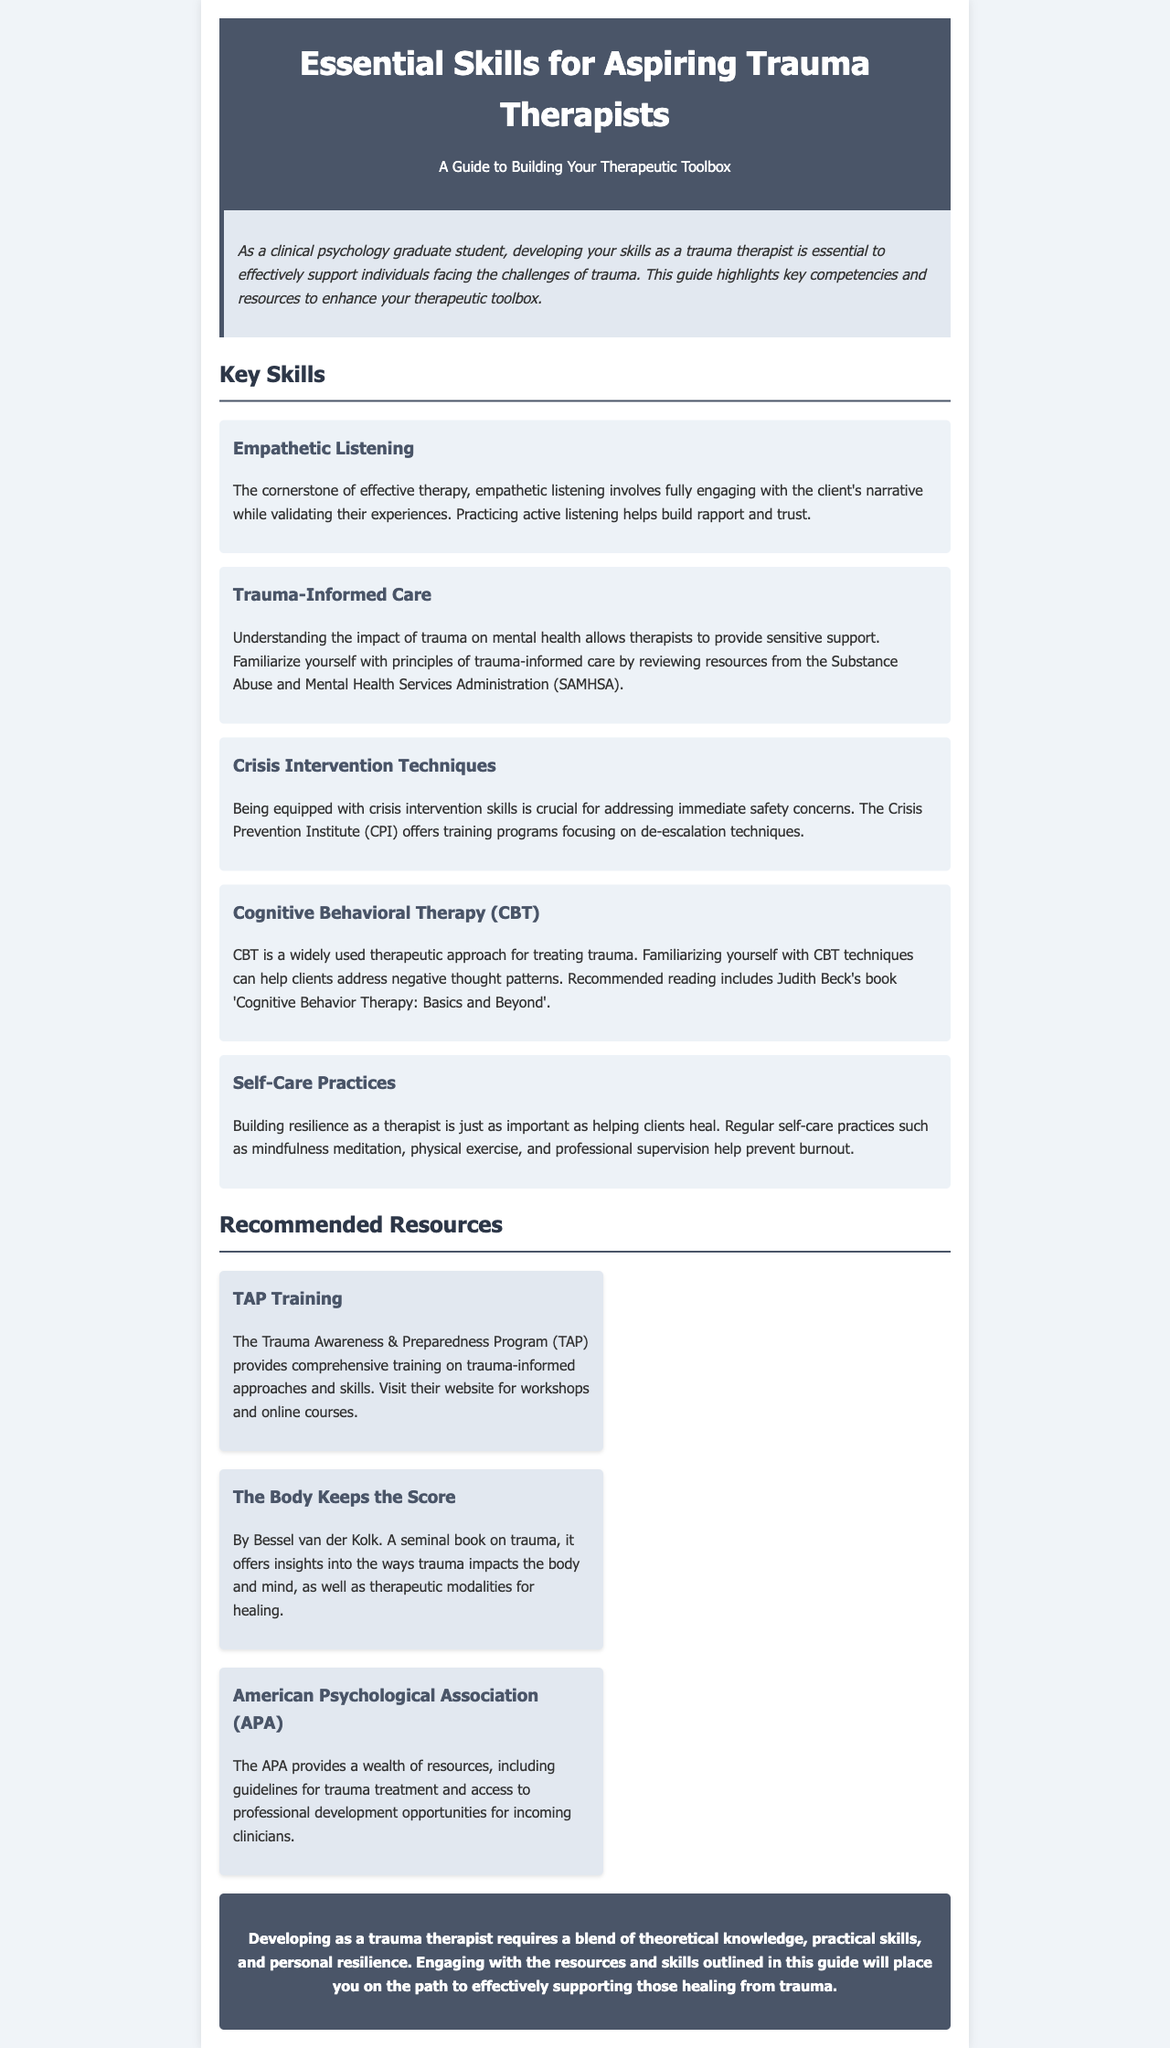What is the main focus of the guide? The guide is centered on developing skills for trauma therapy.
Answer: trauma therapy Who is the author of 'Cognitive Behavior Therapy: Basics and Beyond'? Judith Beck, mentioned in the CBT section, is the author of the referenced book.
Answer: Judith Beck What is the first skill listed in the guide? The first skill mentioned is Empathetic Listening.
Answer: Empathetic Listening Which organization provides training programs on crisis intervention techniques? The Crisis Prevention Institute (CPI) is noted for its training programs in crisis intervention.
Answer: Crisis Prevention Institute What book is recommended for understanding how trauma impacts the body and mind? 'The Body Keeps the Score' by Bessel van der Kolk is recommended for insights into trauma's effects.
Answer: The Body Keeps the Score How many key skills are listed in the document? There are five key skills highlighted in the guide.
Answer: five What is the purpose of self-care practices for therapists? Self-care practices serve to prevent therapist burnout and enhance resilience.
Answer: prevent burnout What does TAP stand for? TAP refers to the Trauma Awareness & Preparedness Program.
Answer: Trauma Awareness & Preparedness Program What kind of guidelines does the American Psychological Association provide? The APA provides guidelines for trauma treatment and access to professional development.
Answer: guidelines for trauma treatment 